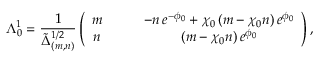<formula> <loc_0><loc_0><loc_500><loc_500>\Lambda _ { 0 } ^ { 1 } = \frac { 1 } { \tilde { \Delta } _ { ( m , n ) } ^ { 1 / 2 } } \left ( \begin{array} { c c } { m \quad } & { { - n \, e ^ { - \phi _ { 0 } } + \chi _ { 0 } \, ( m - \chi _ { 0 } n ) \, e ^ { \phi _ { 0 } } } } \\ { n \quad } & { { ( m - \chi _ { 0 } n ) \, e ^ { \phi _ { 0 } } } } \end{array} \right ) ,</formula> 